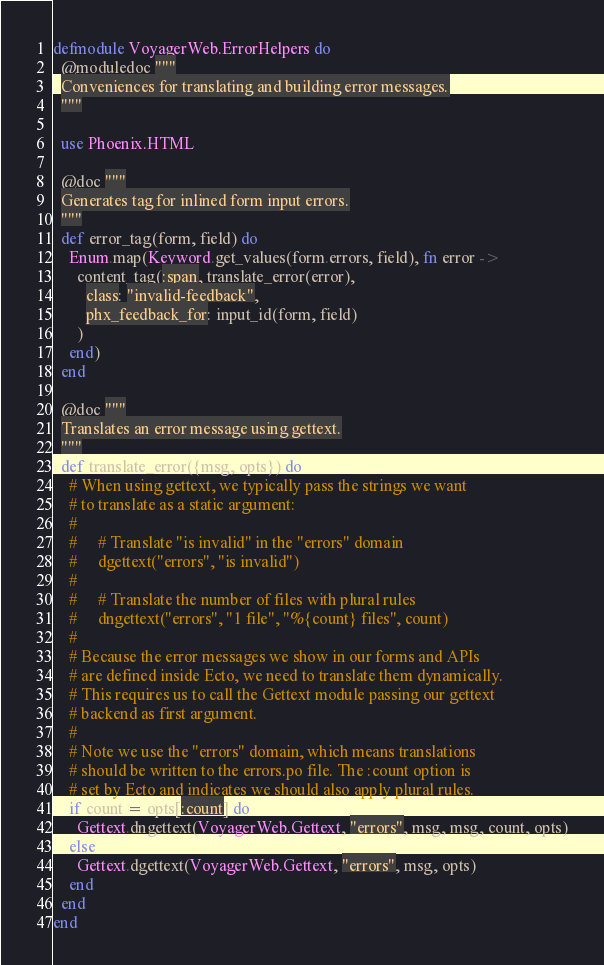Convert code to text. <code><loc_0><loc_0><loc_500><loc_500><_Elixir_>defmodule VoyagerWeb.ErrorHelpers do
  @moduledoc """
  Conveniences for translating and building error messages.
  """

  use Phoenix.HTML

  @doc """
  Generates tag for inlined form input errors.
  """
  def error_tag(form, field) do
    Enum.map(Keyword.get_values(form.errors, field), fn error ->
      content_tag(:span, translate_error(error),
        class: "invalid-feedback",
        phx_feedback_for: input_id(form, field)
      )
    end)
  end

  @doc """
  Translates an error message using gettext.
  """
  def translate_error({msg, opts}) do
    # When using gettext, we typically pass the strings we want
    # to translate as a static argument:
    #
    #     # Translate "is invalid" in the "errors" domain
    #     dgettext("errors", "is invalid")
    #
    #     # Translate the number of files with plural rules
    #     dngettext("errors", "1 file", "%{count} files", count)
    #
    # Because the error messages we show in our forms and APIs
    # are defined inside Ecto, we need to translate them dynamically.
    # This requires us to call the Gettext module passing our gettext
    # backend as first argument.
    #
    # Note we use the "errors" domain, which means translations
    # should be written to the errors.po file. The :count option is
    # set by Ecto and indicates we should also apply plural rules.
    if count = opts[:count] do
      Gettext.dngettext(VoyagerWeb.Gettext, "errors", msg, msg, count, opts)
    else
      Gettext.dgettext(VoyagerWeb.Gettext, "errors", msg, opts)
    end
  end
end
</code> 